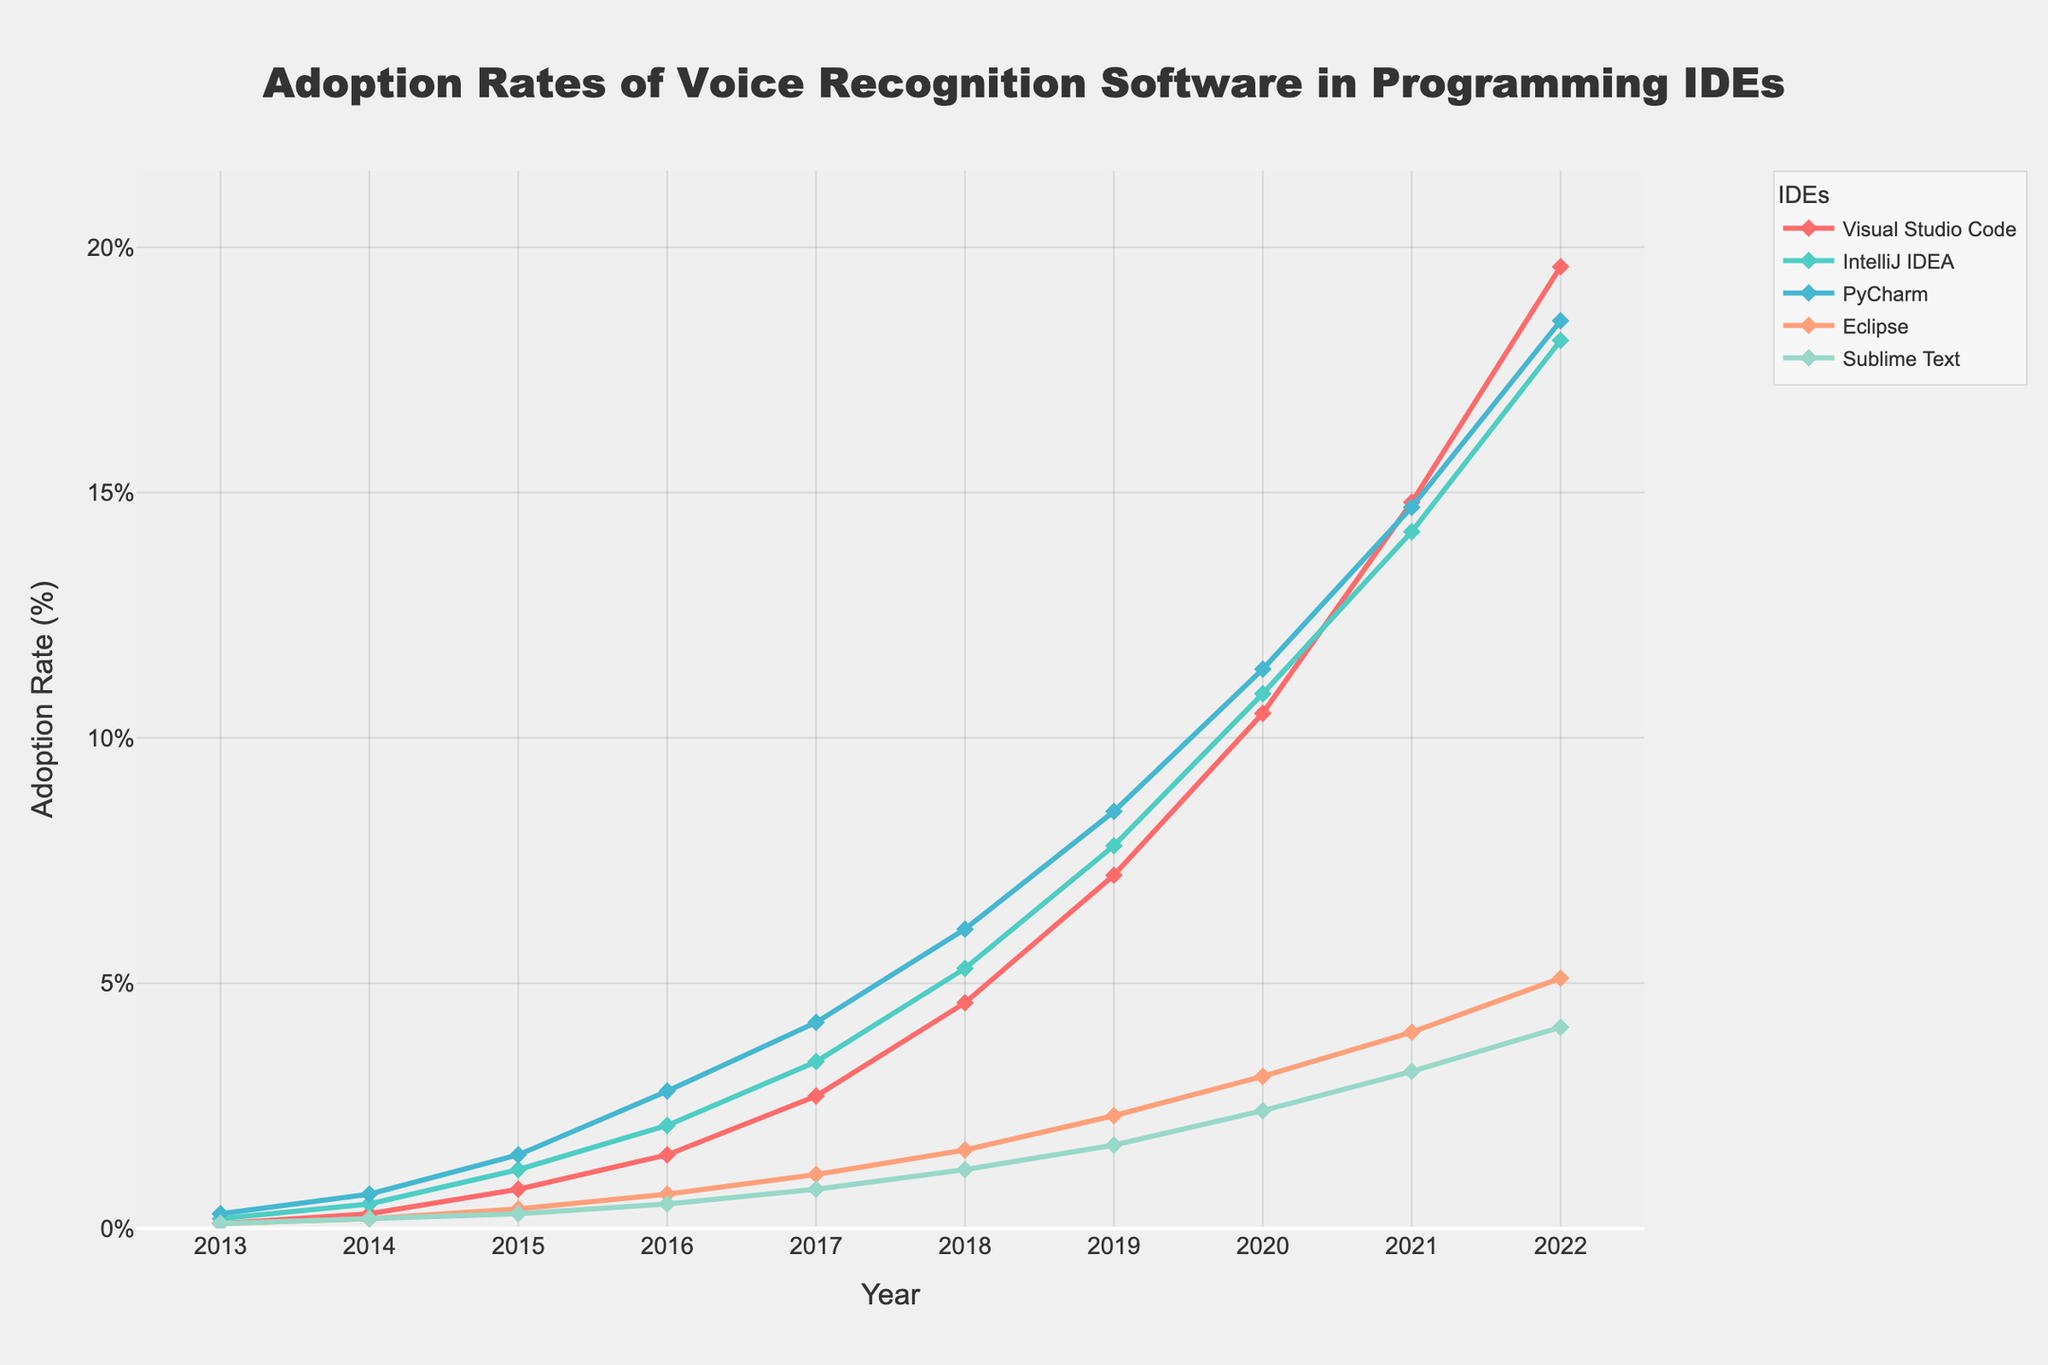What's the highest adoption rate reached by Visual Studio Code and in which year? To find the highest adoption rate for Visual Studio Code, examine its trend line in the chart and identify the peak value and corresponding year. The peak adoption rate is 19.6% in 2022.
Answer: 19.6%, 2022 Which IDE had the least adoption rate of voice recognition software in 2022? Observe the values for all the IDEs in the year 2022. The adoption rates are: Visual Studio Code (19.6%), IntelliJ IDEA (18.1%), PyCharm (18.5%), Eclipse (5.1%), and Sublime Text (4.1%). Sublime Text has the lowest rate.
Answer: Sublime Text How did the adoption rate of IntelliJ IDEA compare to PyCharm in the year 2020? Compare the adoption rates of IntelliJ IDEA and PyCharm in the year 2020 by looking at their respective values in that year. IntellJ IDEA had a rate of 10.9%, and PyCharm had 11.4%.
Answer: PyCharm higher Between which two consecutive years did Visual Studio Code see the largest increase in adoption rate? Examine the change in Visual Studio Code's adoption rate year-over-year. Calculate the differences: 2014-2013 (0.2), 2015-2014 (0.5), 2016-2015 (0.7), 2017-2016 (1.2), 2018-2017 (1.9), 2019-2018 (2.6), 2020-2019 (3.3), 2021-2020 (4.3), and 2022-2021 (4.8). The largest increase occurred between 2021 and 2022.
Answer: 2021-2022 What was the average adoption rate of PyCharm over the entire period? Calculate the average by summing the adoption rates of PyCharm over the given years and dividing by the number of years: (0.3 + 0.7 + 1.5 + 2.8 + 4.2 + 6.1 + 8.5 + 11.4 + 14.7 + 18.5)/10 = 6.87%.
Answer: 6.87% Which year showed the most significant increase in adoption rate for Eclipse? Calculate the year-over-year adoption rate increases for Eclipse: 2014-2013 (0.1), 2015-2014 (0.2), 2016-2015 (0.3), 2017-2016 (0.4), 2018-2017 (0.5), 2019-2018 (0.7), 2020-2019 (0.8), 2021-2020 (0.9), and 2022-2021 (1.1). The most significant increase was between 2021 and 2022.
Answer: 2021-2022 On average, how did the adoption rates of voice recognition software across all IDEs change each year from 2013 to 2022? Calculate the yearly average of all IDEs and find the change year-over-year. Assessing each year’s average gives insights into year-over-year change trends. The average across all years is obtained and compared, showing a generally increasing trend.
Answer: Increasing trend 